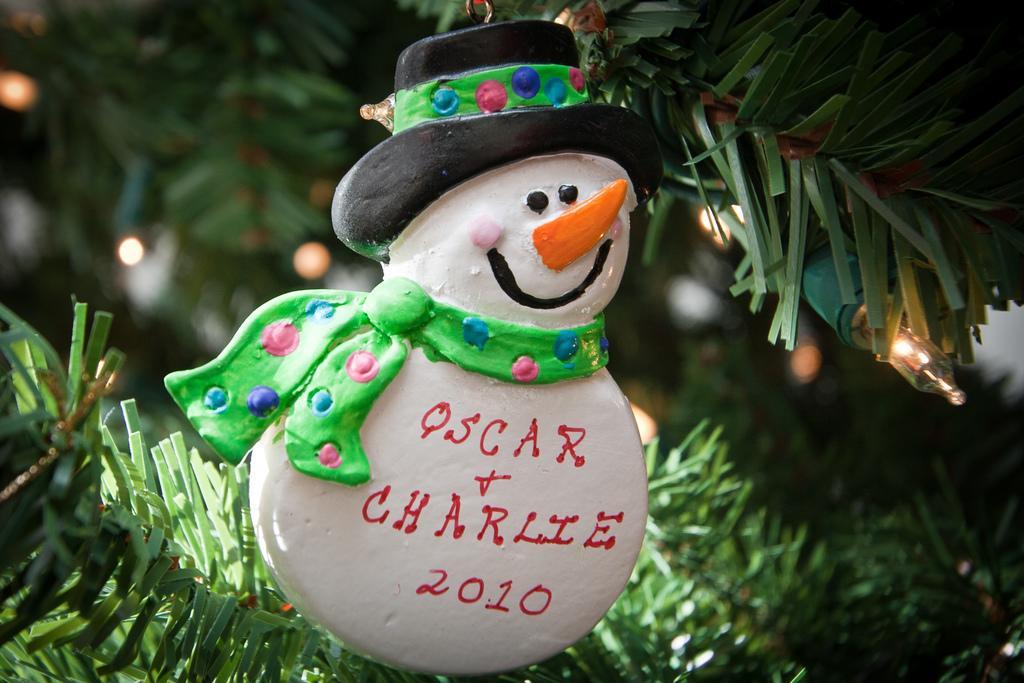Can you describe this image briefly? This is the picture of a doll and behind there are some leaves and a bulb. 